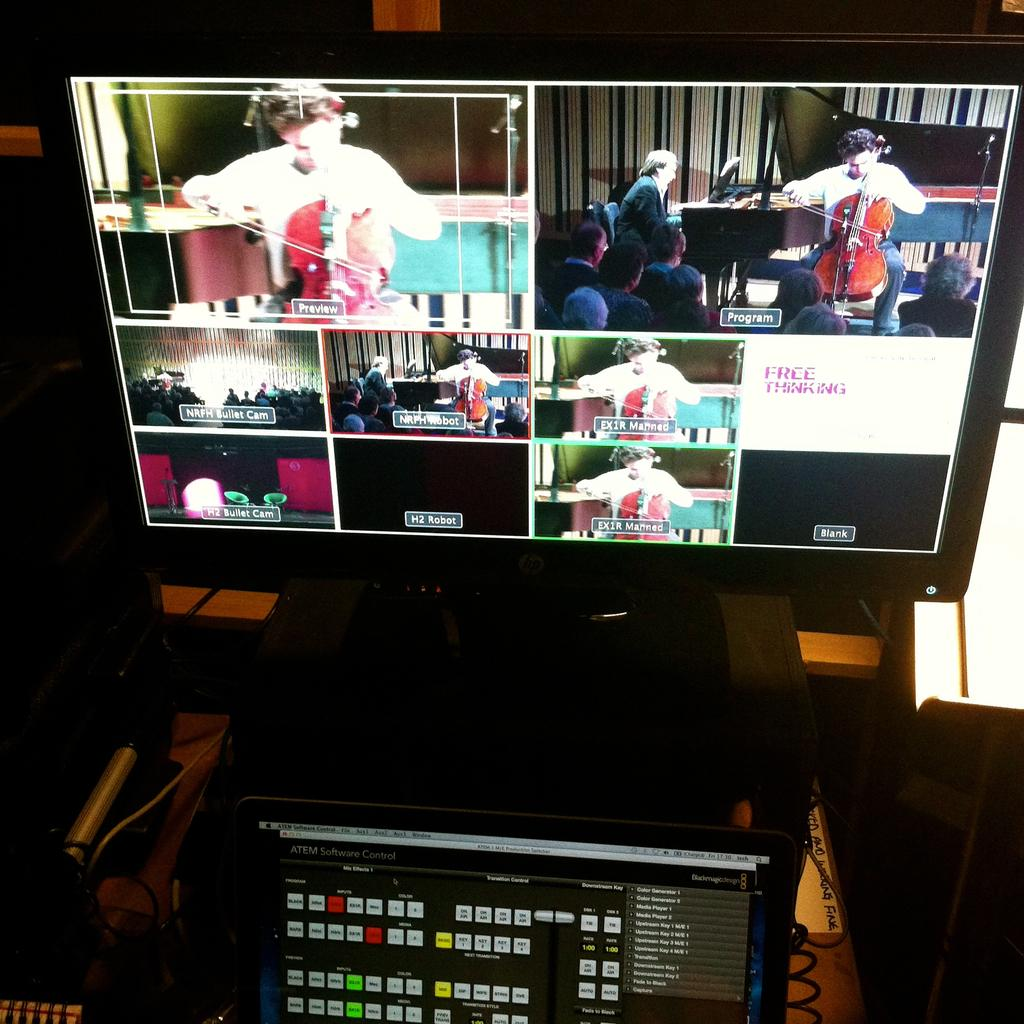What is the main object in the image? There is a screen in the image. What is shown on the screen? Images are displayed on the screen. What other object is present at the bottom of the image? There is a display board at the bottom of the image. How many giraffes can be seen on the screen in the image? There are no giraffes present in the image, as the screen displays images, but no specific animals are mentioned. 